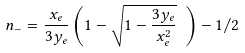Convert formula to latex. <formula><loc_0><loc_0><loc_500><loc_500>n _ { - } = \frac { x _ { e } } { 3 y _ { e } } \left ( 1 - \sqrt { 1 - \frac { 3 y _ { e } } { x _ { e } ^ { 2 } } } \ \right ) - 1 / 2</formula> 